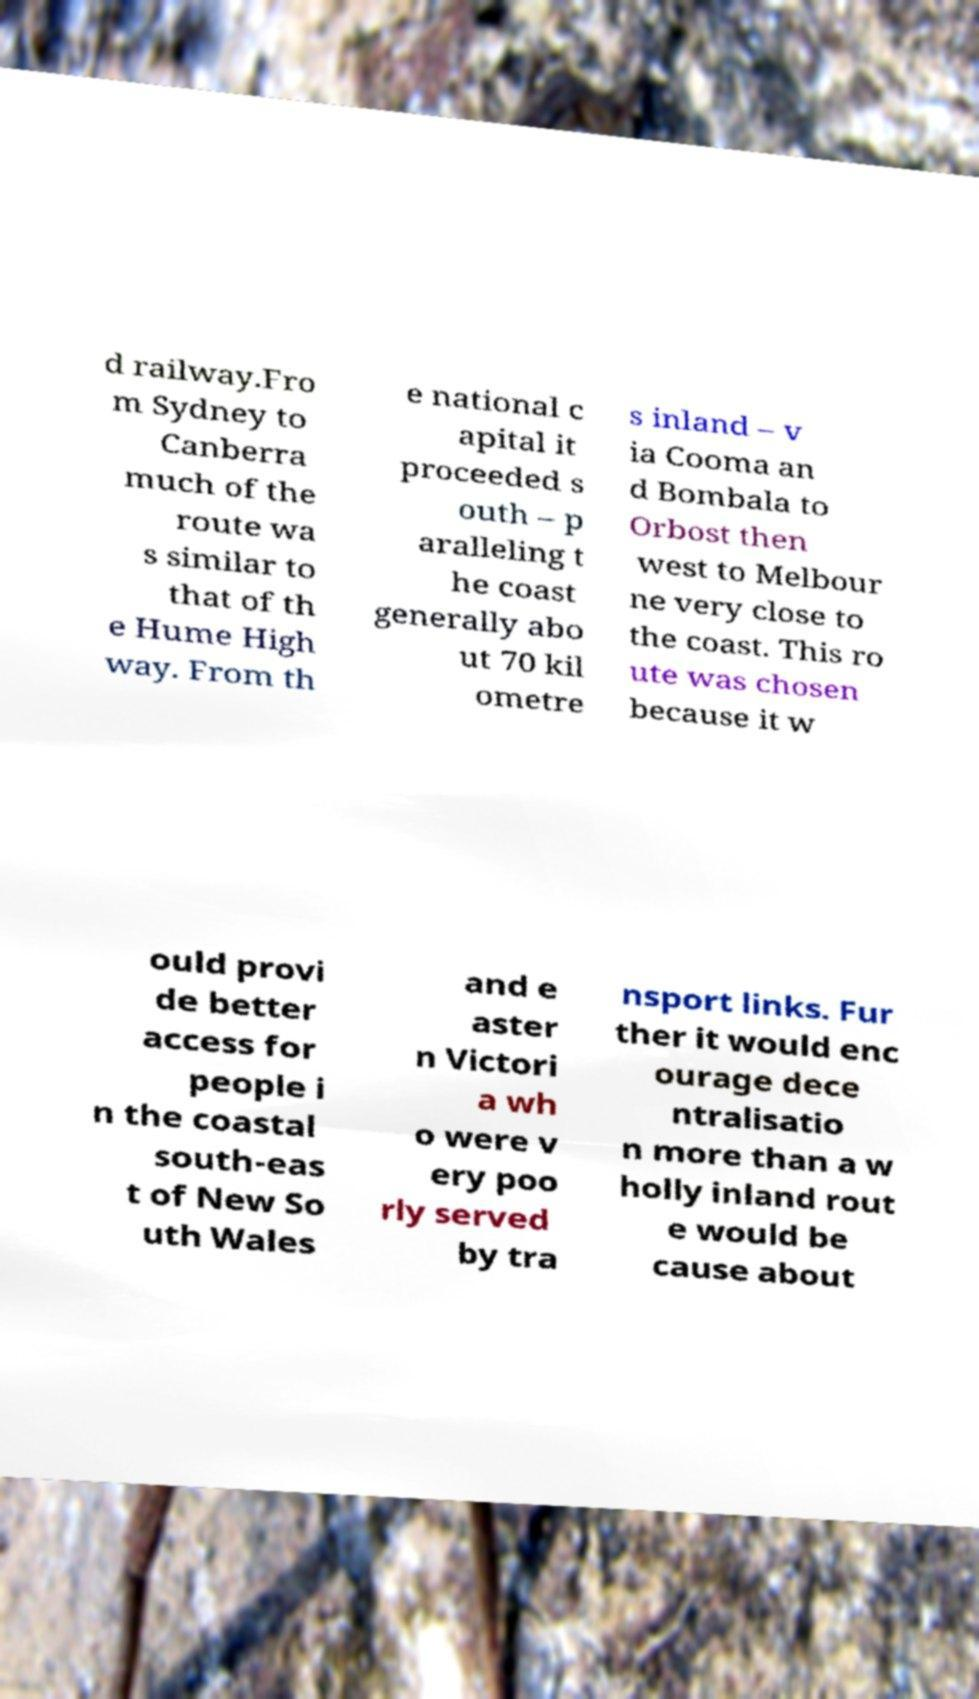I need the written content from this picture converted into text. Can you do that? d railway.Fro m Sydney to Canberra much of the route wa s similar to that of th e Hume High way. From th e national c apital it proceeded s outh – p aralleling t he coast generally abo ut 70 kil ometre s inland – v ia Cooma an d Bombala to Orbost then west to Melbour ne very close to the coast. This ro ute was chosen because it w ould provi de better access for people i n the coastal south-eas t of New So uth Wales and e aster n Victori a wh o were v ery poo rly served by tra nsport links. Fur ther it would enc ourage dece ntralisatio n more than a w holly inland rout e would be cause about 